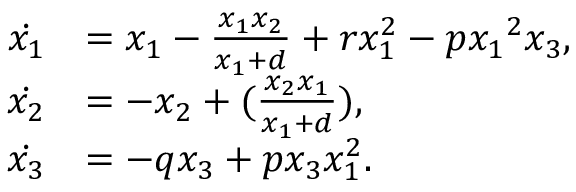<formula> <loc_0><loc_0><loc_500><loc_500>\begin{array} { r l } { \dot { { x } _ { 1 } } } & { = { x } _ { 1 } - \frac { { x } _ { 1 } { x } _ { 2 } } { { x } _ { 1 } + d } + { r } { x } _ { 1 } ^ { 2 } - { p } { { { x } _ { 1 } } ^ { 2 } } { x } _ { 3 } , } \\ { { \dot { { x } _ { 2 } } } } & { = - { x } _ { 2 } + ( \frac { { x } _ { 2 } { x } _ { 1 } } { { x } _ { 1 } + d } ) , } \\ { { \dot { { x } _ { 3 } } } } & { = - { q } { x } _ { 3 } + { p } { x } _ { 3 } { x } _ { 1 } ^ { 2 } . } \end{array}</formula> 